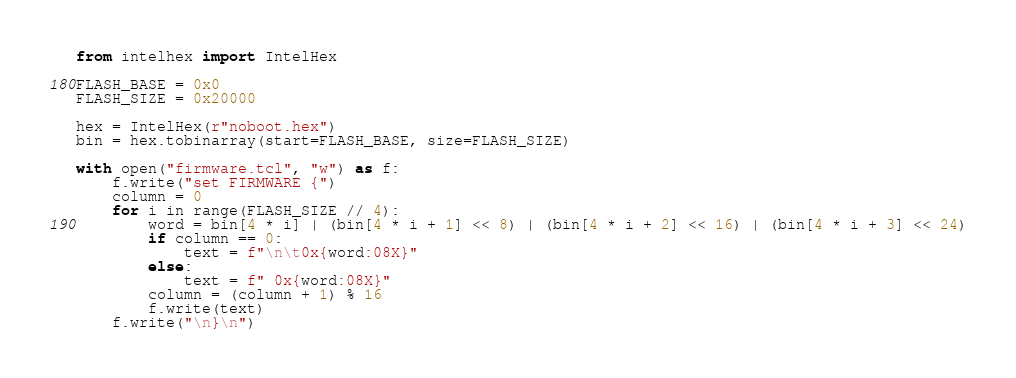<code> <loc_0><loc_0><loc_500><loc_500><_Python_>from intelhex import IntelHex

FLASH_BASE = 0x0
FLASH_SIZE = 0x20000

hex = IntelHex(r"noboot.hex")
bin = hex.tobinarray(start=FLASH_BASE, size=FLASH_SIZE)

with open("firmware.tcl", "w") as f:
    f.write("set FIRMWARE {")
    column = 0
    for i in range(FLASH_SIZE // 4):
        word = bin[4 * i] | (bin[4 * i + 1] << 8) | (bin[4 * i + 2] << 16) | (bin[4 * i + 3] << 24)
        if column == 0:
            text = f"\n\t0x{word:08X}"
        else:
            text = f" 0x{word:08X}"
        column = (column + 1) % 16
        f.write(text)
    f.write("\n}\n")
</code> 